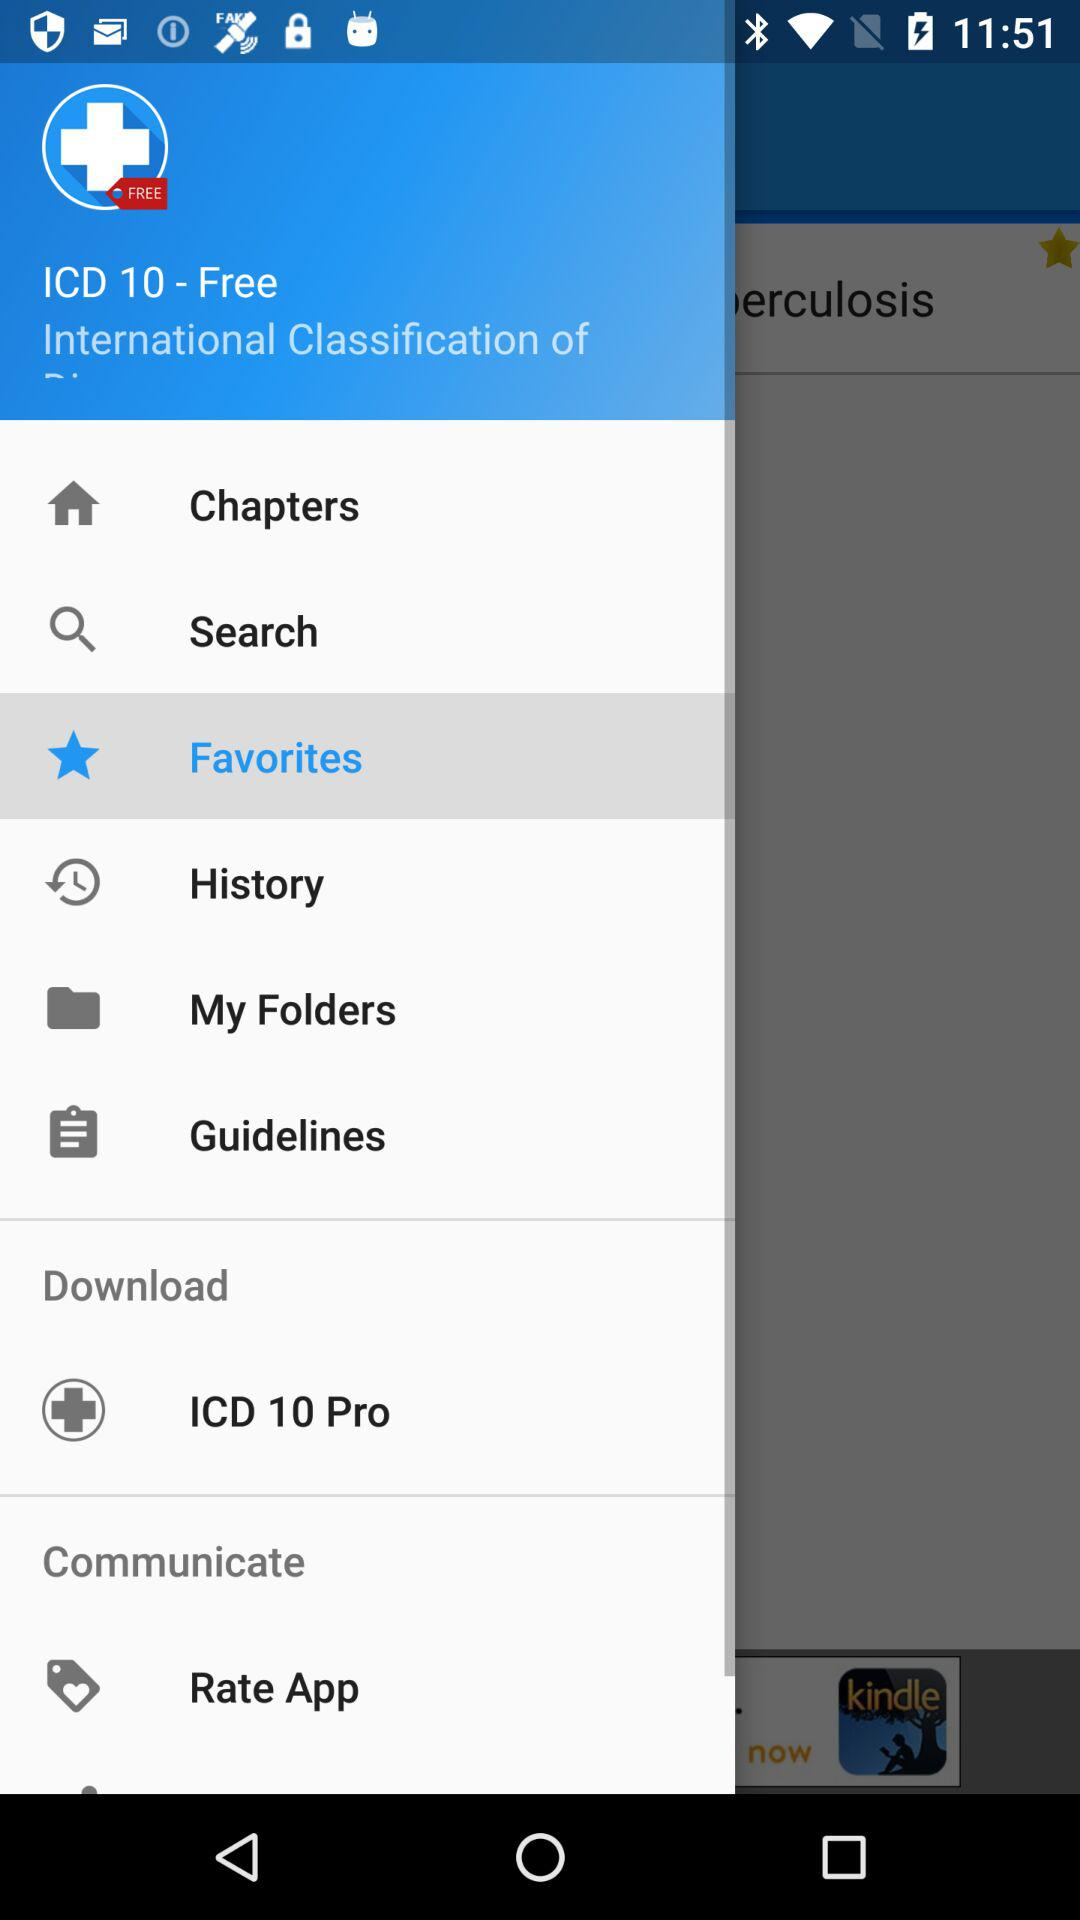How many notifications are there in "History"?
When the provided information is insufficient, respond with <no answer>. <no answer> 